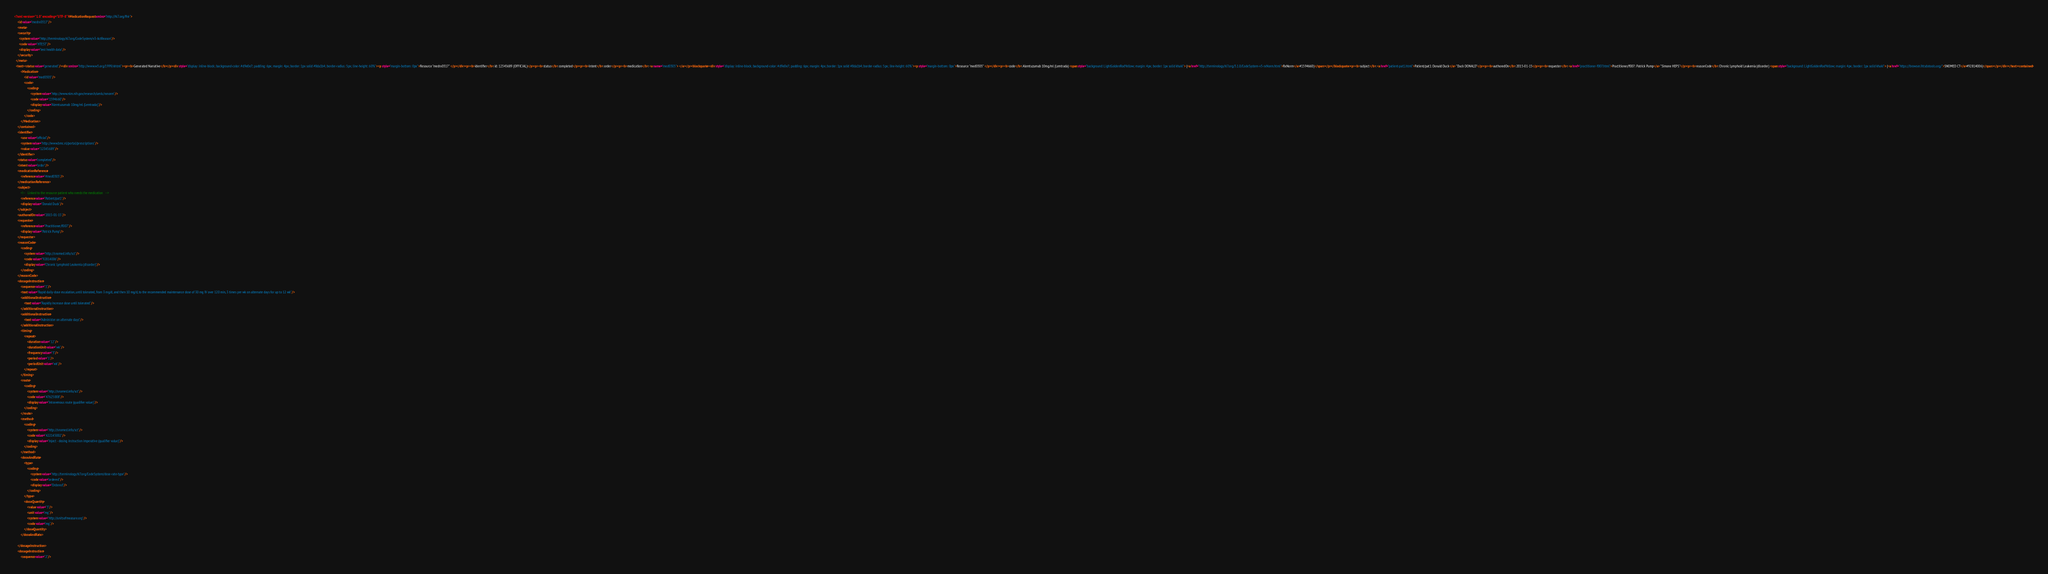<code> <loc_0><loc_0><loc_500><loc_500><_XML_><?xml version="1.0" encoding="UTF-8"?><MedicationRequest xmlns="http://hl7.org/fhir">
    <id value="medrx0317"/>
    <meta>
    <security>
      <system value="http://terminology.hl7.org/CodeSystem/v3-ActReason"/>
      <code value="HTEST"/>
      <display value="test health data"/>
    </security>
  </meta>
  <text><status value="generated"/><div xmlns="http://www.w3.org/1999/xhtml"><p><b>Generated Narrative</b></p><div style="display: inline-block; background-color: #d9e0e7; padding: 6px; margin: 4px; border: 1px solid #8da1b4; border-radius: 5px; line-height: 60%"><p style="margin-bottom: 0px">Resource "medrx0317" </p></div><p><b>identifier</b>: id: 12345689 (OFFICIAL)</p><p><b>status</b>: completed</p><p><b>intent</b>: order</p><p><b>medication</b>: <a name="med0303"> </a></p><blockquote><div style="display: inline-block; background-color: #d9e0e7; padding: 6px; margin: 4px; border: 1px solid #8da1b4; border-radius: 5px; line-height: 60%"><p style="margin-bottom: 0px">Resource "med0303" </p></div><p><b>code</b>: Alemtuzumab 10mg/ml (Lemtrada) <span style="background: LightGoldenRodYellow; margin: 4px; border: 1px solid khaki"> (<a href="http://terminology.hl7.org/3.1.0/CodeSystem-v3-rxNorm.html">RxNorm</a>#1594660)</span></p></blockquote><p><b>subject</b>: <a href="patient-pat1.html">Patient/pat1: Donald Duck</a> "Duck DONALD"</p><p><b>authoredOn</b>: 2015-01-15</p><p><b>requester</b>: <a href="practitioner-f007.html">Practitioner/f007: Patrick Pump</a> "Simone HEPS"</p><p><b>reasonCode</b>: Chronic Lymphoid Leukemia (disorder) <span style="background: LightGoldenRodYellow; margin: 4px; border: 1px solid khaki"> (<a href="https://browser.ihtsdotools.org/">SNOMED CT</a>#92814006)</span></p></div></text><contained>
        <Medication>
            <id value="med0303"/>
            <code>
                <coding>
                    <system value="http://www.nlm.nih.gov/research/umls/rxnorm"/>
                    <code value="1594660"/>
                    <display value="Alemtuzumab 10mg/ml (Lemtrada)"/>
                </coding>
            </code>
        </Medication>
    </contained>
    <identifier>
        <use value="official"/>
        <system value="http://www.bmc.nl/portal/prescriptions"/>
        <value value="12345689"/>
    </identifier>
    <status value="completed"/>
    <intent value="order"/>
    <medicationReference>
        <reference value="#med0303"/>
    </medicationReference>
    <subject>
        <!--   Linked to the resource patient who needs the medication   -->
        <reference value="Patient/pat1"/>
        <display value="Donald Duck"/>
    </subject>
    <authoredOn value="2015-01-15"/>
    <requester>
        <reference value="Practitioner/f007"/>
        <display value="Patrick Pump"/>
    </requester>
    <reasonCode>
        <coding>
            <system value="http://snomed.info/sct"/>
            <code value="92814006"/>
            <display value="Chronic Lymphoid Leukemia (disorder)"/>
        </coding>
    </reasonCode>
    <dosageInstruction>
        <sequence value="1"/>
        <text value="Rapid daily-dose escalation, until tolerated, from 3 mg/d, and then 10 mg/d, to the recommended maintenance dose of 30 mg IV over 120 min, 3 times per wk on alternate days for up to 12 wk"/>
        <additionalInstruction>
            <text value="Rapidly increase dose until tolerated"/>
        </additionalInstruction>
        <additionalInstruction>
            <text value="Administer on alternate days"/>
        </additionalInstruction>
        <timing>
            <repeat>
                <duration value="12"/>
                <durationUnit value="wk"/>
                <frequency value="3"/>
                <period value="1"/>
                <periodUnit value="wk"/>
            </repeat>
        </timing>
        <route>
            <coding>
                <system value="http://snomed.info/sct"/>
                <code value="47625008"/>
                <display value="Intravenous route (qualifier value)"/>
            </coding>
        </route>
        <method>
            <coding>
                <system value="http://snomed.info/sct"/>
                <code value="422145002"/>
                <display value="Inject - dosing instruction imperative (qualifier value)"/>
            </coding>
        </method>
        <doseAndRate>
            <type>
                <coding>
                    <system value="http://terminology.hl7.org/CodeSystem/dose-rate-type"/>
                    <code value="ordered"/>
                    <display value="Ordered"/>
                </coding>
            </type>
            <doseQuantity>
                <value value="3"/>
                <unit value="mg"/>
                <system value="http://unitsofmeasure.org"/>
                <code value="mg"/>
            </doseQuantity>
        </doseAndRate>
        
    </dosageInstruction>
    <dosageInstruction>
        <sequence value="2"/></code> 